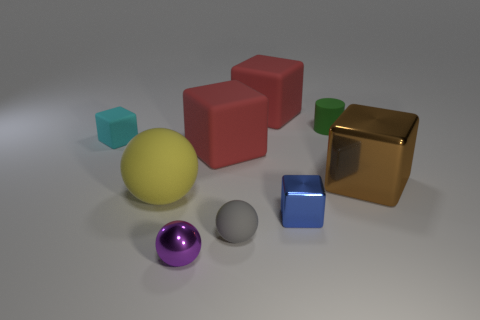How many things are either large cubes or brown things?
Your answer should be very brief. 3. What is the shape of the blue shiny object?
Make the answer very short. Cube. The blue thing that is the same shape as the large brown shiny thing is what size?
Keep it short and to the point. Small. There is a cube left of the matte ball that is on the left side of the tiny purple sphere; how big is it?
Give a very brief answer. Small. Are there the same number of tiny rubber blocks that are left of the tiny cyan matte thing and purple metal blocks?
Offer a terse response. Yes. How many other objects are there of the same color as the cylinder?
Provide a succinct answer. 0. Is the number of tiny cyan matte blocks that are behind the yellow object less than the number of large blue metal things?
Offer a terse response. No. Is there a red thing that has the same size as the yellow rubber sphere?
Offer a terse response. Yes. Does the big metal object have the same color as the small cube that is to the right of the tiny cyan rubber cube?
Provide a short and direct response. No. What number of green matte cylinders are behind the small blue thing behind the tiny gray matte thing?
Give a very brief answer. 1. 